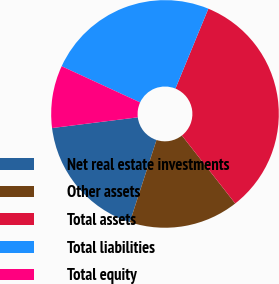Convert chart to OTSL. <chart><loc_0><loc_0><loc_500><loc_500><pie_chart><fcel>Net real estate investments<fcel>Other assets<fcel>Total assets<fcel>Total liabilities<fcel>Total equity<nl><fcel>18.02%<fcel>15.59%<fcel>33.19%<fcel>24.34%<fcel>8.86%<nl></chart> 